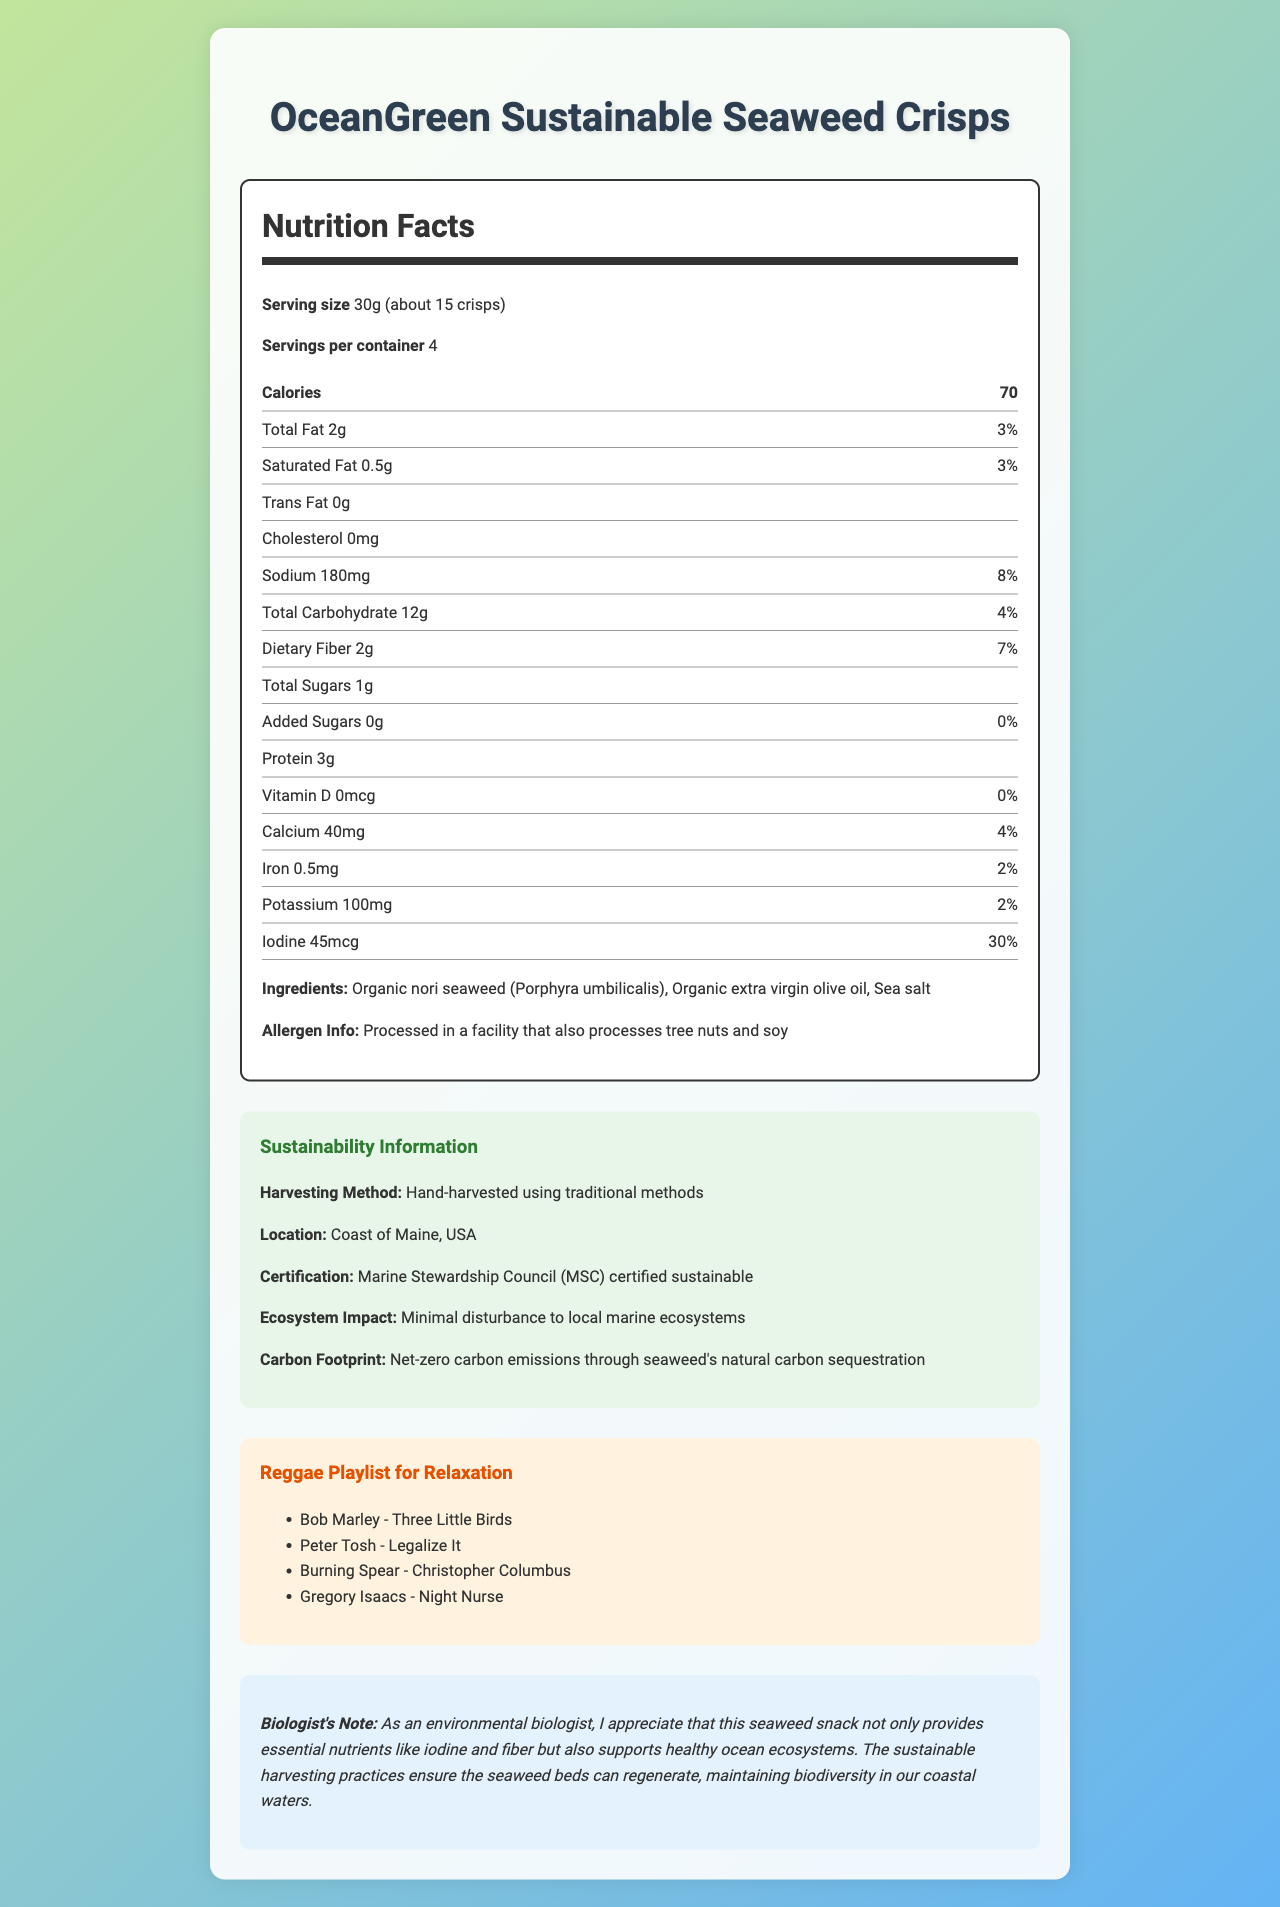what is the serving size of OceanGreen Sustainable Seaweed Crisps? The serving size is explicitly mentioned at the top of the Nutrition Facts section.
Answer: 30g (about 15 crisps) how many calories are there per serving? The calorie count is listed prominently in the Nutrition Facts section.
Answer: 70 what is the daily value percentage for total fat? The daily value percentage for total fat is indicated next to the total fat amount.
Answer: 3% how much dietary fiber does one serving contain? The dietary fiber content is listed under the Total Carbohydrate section in the Nutrition Facts.
Answer: 2g what is the harvesting location for the seaweed used in this product? The sustainability information section notes that the seaweed is harvested off the coast of Maine.
Answer: Coast of Maine, USA Is there any cholesterol in this seaweed snack? The Nutrition Facts section indicates that cholesterol is 0mg.
Answer: No Which of the following ingredients is not in the seaweed crisps? A. Organic nori seaweed B. Organic extra virgin olive oil C. Sea salt D. Palm oil The ingredients listed are organic nori seaweed, organic extra virgin olive oil, and sea salt. Palm oil is not included.
Answer: D What certification does this product hold regarding sustainability? A. USDA Organic B. Fair Trade C. Marine Stewardship Council (MSC) D. Non-GMO Project Verified The sustainability information states that the product is certified by the Marine Stewardship Council (MSC).
Answer: C what is the primary impact of the sustainable harvesting practice mentioned? A. Increased carbon emissions B. Minimal disturbance to local marine ecosystems C. Overharvesting of seaweed D. Increased use of pesticides The sustainability information section states that the harvesting method has minimal disturbance to local marine ecosystems.
Answer: B does the product contain any added sugars? The Nutrition Facts label shows 0g of added sugars.
Answer: No what are the main sources of protein in this snack? The ingredients list mentions organic nori seaweed, which is a source of protein.
Answer: organic nori seaweed what is the allergen information for this product? The allergen information is explicitly noted.
Answer: Processed in a facility that also processes tree nuts and soy what is the main idea of this document? The document contains a comprehensive overview of the product’s nutritional facts, ingredients, allergen details, sustainability certifications, and even a biologist's note highlighting the environmental benefits of its harvesting practices.
Answer: The document provides nutritional information, sustainability practices, and additional features of OceanGreen Sustainable Seaweed Crisps, emphasizing its health benefits and eco-friendly harvesting methods. what is the iodine content in a single serving? The iodine content is listed in the Nutrition Facts section.
Answer: 45mcg Which song is not included in the reggae playlist provided in the document? A. Bob Marley - Three Little Birds B. Peter Tosh - Legalize It C. Burning Spear - Christopher Columbus D. Toots and the Maytals - Pressure Drop The reggae playlist includes the first three songs. "Toots and the Maytals - Pressure Drop" is not listed.
Answer: D does this product contribute to net-zero carbon emissions? The sustainability information section states that the seaweed’s natural carbon sequestration contributes to net-zero carbon emissions.
Answer: Yes what is the exact amount of iron in each serving? The iron content is provided in the Nutrition Facts section.
Answer: 0.5mg What is the cost of the Seaweed Crisps? The document does not include any pricing information.
Answer: Not enough information 